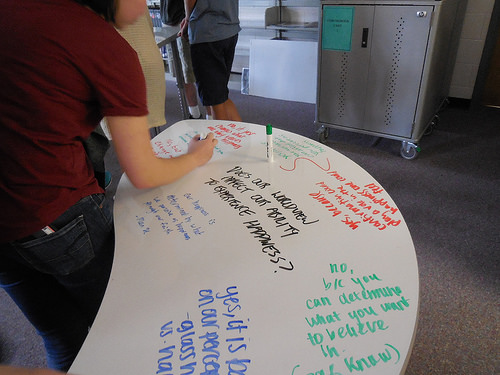<image>
Can you confirm if the word is on the table? Yes. Looking at the image, I can see the word is positioned on top of the table, with the table providing support. 